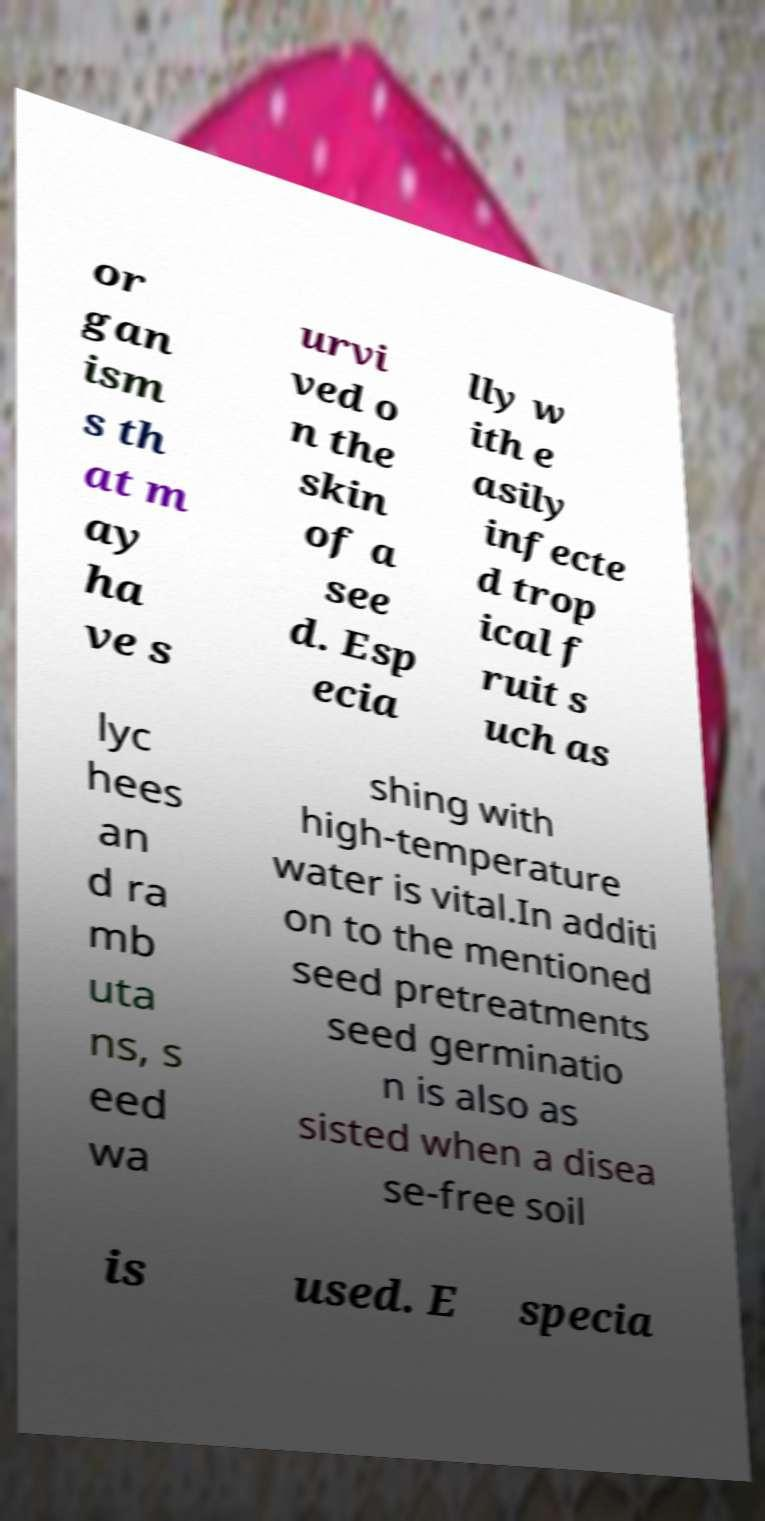Could you assist in decoding the text presented in this image and type it out clearly? or gan ism s th at m ay ha ve s urvi ved o n the skin of a see d. Esp ecia lly w ith e asily infecte d trop ical f ruit s uch as lyc hees an d ra mb uta ns, s eed wa shing with high-temperature water is vital.In additi on to the mentioned seed pretreatments seed germinatio n is also as sisted when a disea se-free soil is used. E specia 